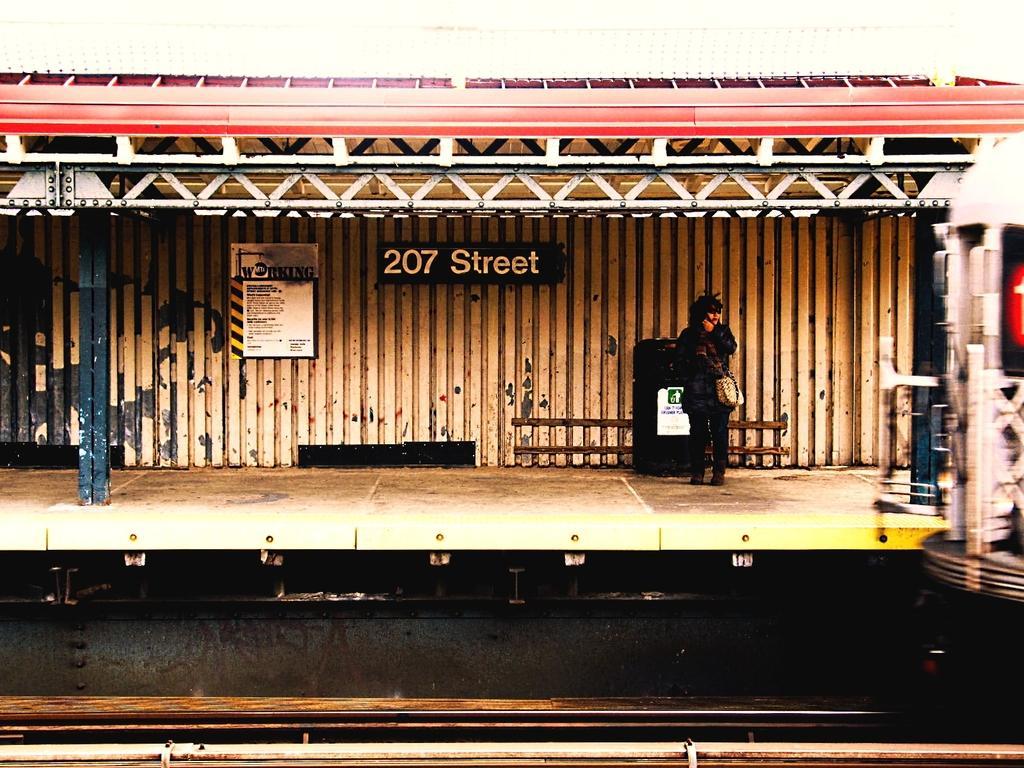In one or two sentences, can you explain what this image depicts? In this image in the center there is a person standing. In the background there is tin wall and on this wall there are boards with some text and numbers written on it. On the top there is a shelter which is red in colour and there is a pole which is black in colour. 